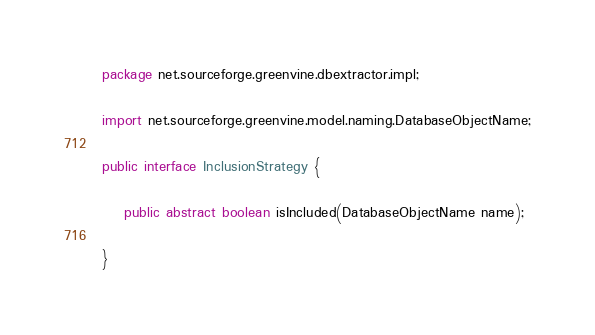<code> <loc_0><loc_0><loc_500><loc_500><_Java_>package net.sourceforge.greenvine.dbextractor.impl;

import net.sourceforge.greenvine.model.naming.DatabaseObjectName;

public interface InclusionStrategy {
    
    public abstract boolean isIncluded(DatabaseObjectName name);

}
</code> 